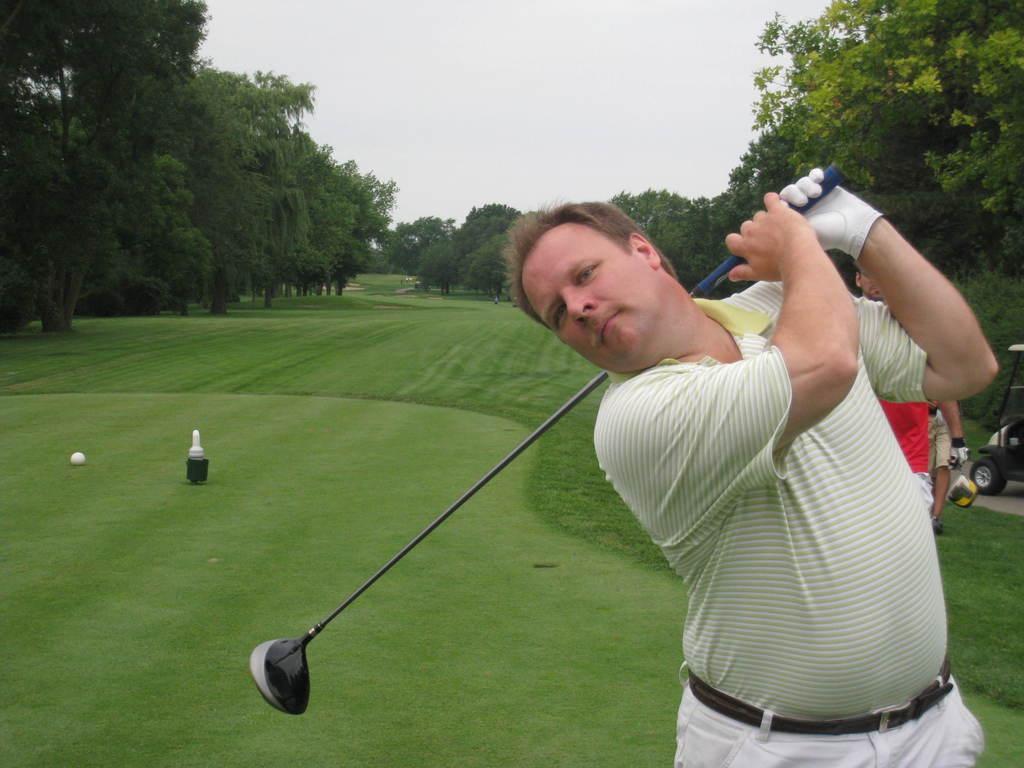Describe this image in one or two sentences. In this image on the right, there is a man, he wears a t shirt, trouser, belt, he is holding a stick. On the left there are trees, grass and ball. On the right there are some people, vehicle, trees and sky. 